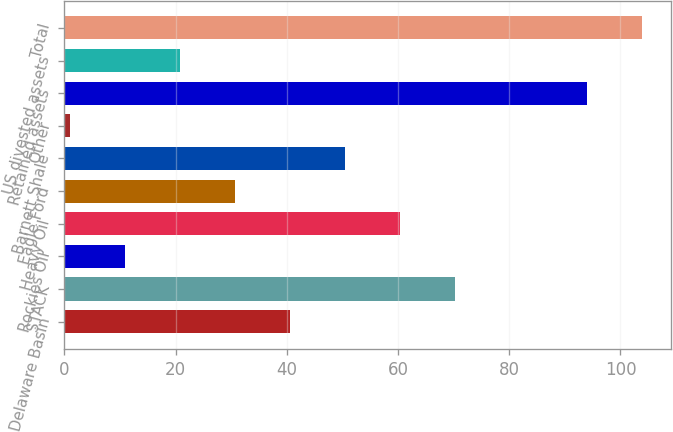Convert chart to OTSL. <chart><loc_0><loc_0><loc_500><loc_500><bar_chart><fcel>Delaware Basin<fcel>STACK<fcel>Rockies Oil<fcel>Heavy Oil<fcel>Eagle Ford<fcel>Barnett Shale<fcel>Other<fcel>Retained assets<fcel>US divested assets<fcel>Total<nl><fcel>40.6<fcel>70.3<fcel>10.9<fcel>60.4<fcel>30.7<fcel>50.5<fcel>1<fcel>94<fcel>20.8<fcel>103.9<nl></chart> 